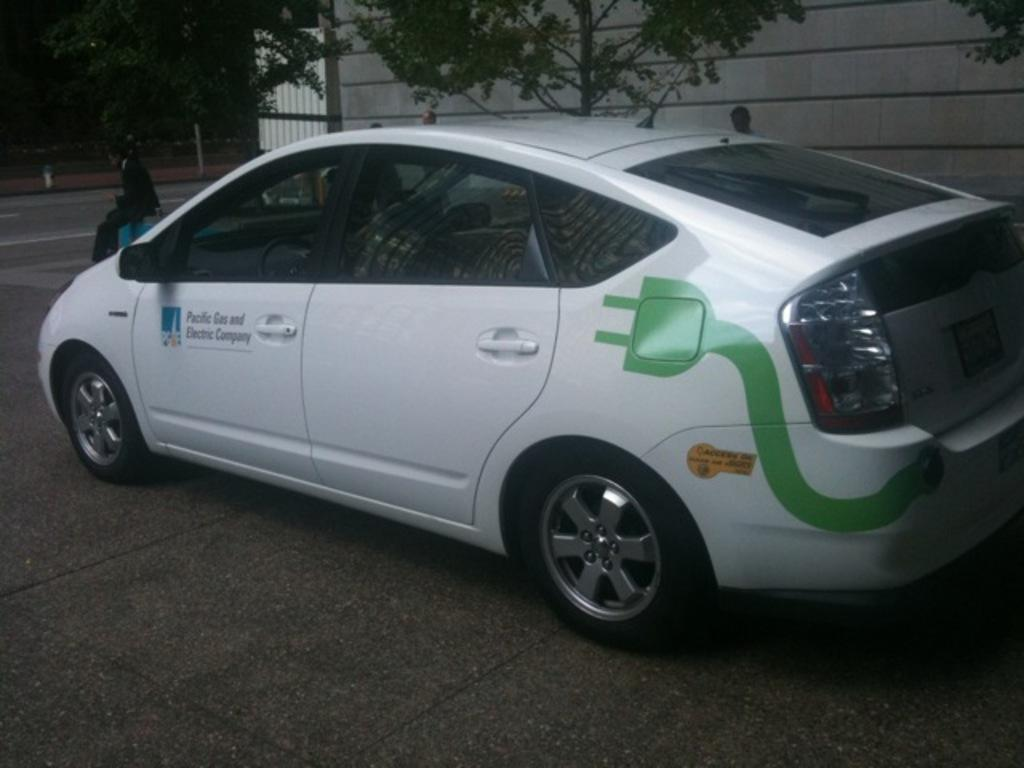What is the main subject of the image? There is a car in the image. What else can be seen in the image besides the car? There are people on the road and a building, trees, a metal pole, and some unspecified objects in the background of the image. Can you describe the setting of the image? The image shows a car on a road with people, and there are various objects and structures in the background, including a building, trees, and a metal pole. What type of smell can be detected coming from the car in the image? There is no information about any smell in the image, so it cannot be determined from the image. 